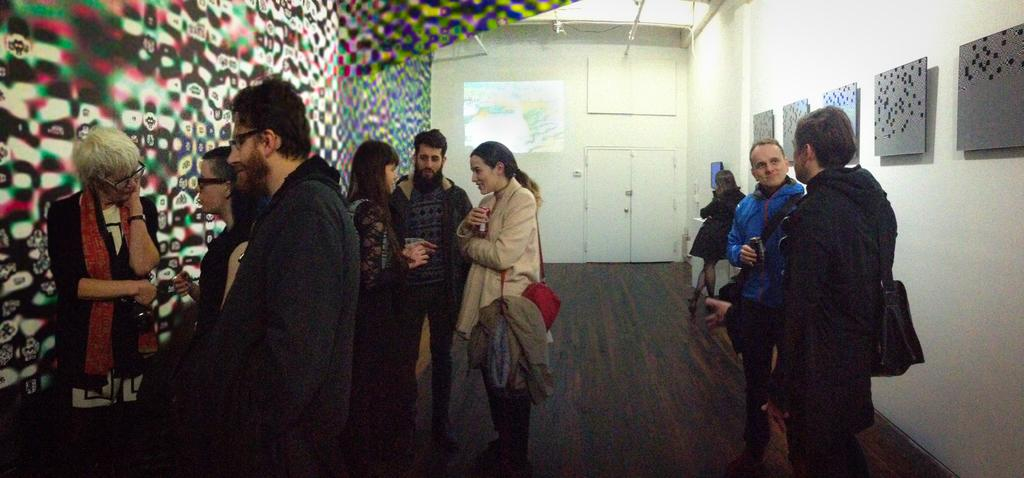How many people are in the image? There is a group of people in the image, but the exact number is not specified. What are the people in the image doing? The people are on the ground, but their specific activity is not mentioned. What can be seen in the background of the image? There is a wall in the background of the image, and there are boards on the wall. What type of brake system can be seen on the trains in the image? There are no trains present in the image; it features a group of people on the ground with a wall and boards in the background. 